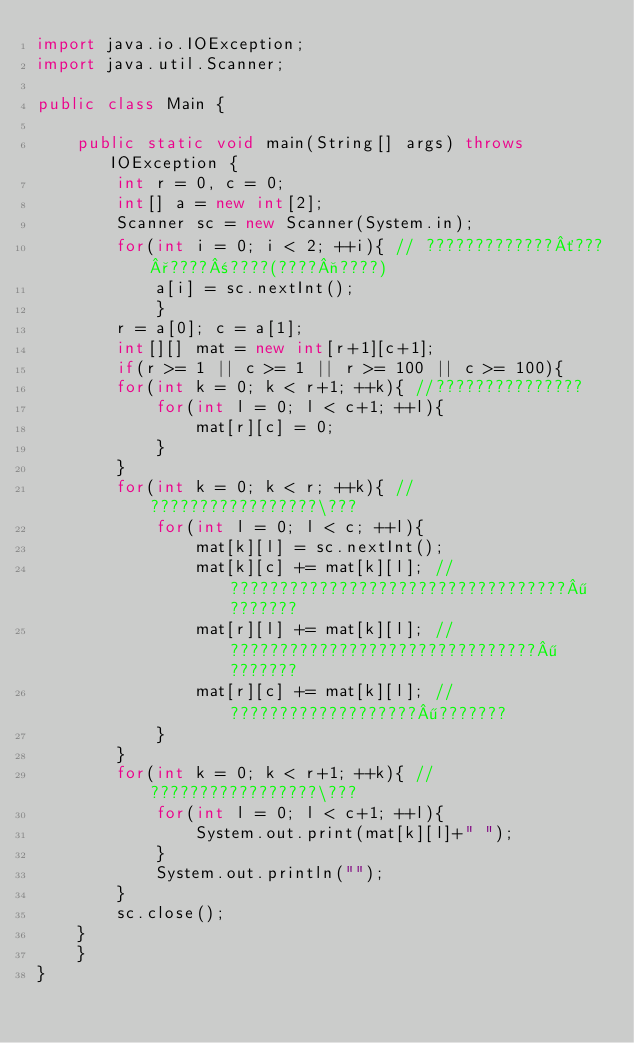Convert code to text. <code><loc_0><loc_0><loc_500><loc_500><_Java_>import java.io.IOException;
import java.util.Scanner;

public class Main {

	public static void main(String[] args) throws IOException {
		int r = 0, c = 0;
		int[] a = new int[2];
		Scanner sc = new Scanner(System.in);
		for(int i = 0; i < 2; ++i){ // ?????????????´???°????±????(????¬????)
			a[i] = sc.nextInt();
			}
		r = a[0]; c = a[1];
		int[][] mat = new int[r+1][c+1];
		if(r >= 1 || c >= 1 || r >= 100 || c >= 100){
		for(int k = 0; k < r+1; ++k){ //???????????????
			for(int l = 0; l < c+1; ++l){
				mat[r][c] = 0;
			}
		}
		for(int k = 0; k < r; ++k){ //?????????????????\???
			for(int l = 0; l < c; ++l){
				mat[k][l] = sc.nextInt();
				mat[k][c] += mat[k][l]; //??????????????????????????????????¶???????
				mat[r][l] += mat[k][l]; //???????????????????????????????¶???????
				mat[r][c] += mat[k][l]; //???????????????????¶???????
			}
		}
		for(int k = 0; k < r+1; ++k){ //?????????????????\???
			for(int l = 0; l < c+1; ++l){
				System.out.print(mat[k][l]+" ");
			}
			System.out.println("");
		}
		sc.close();
	}
	}
}</code> 